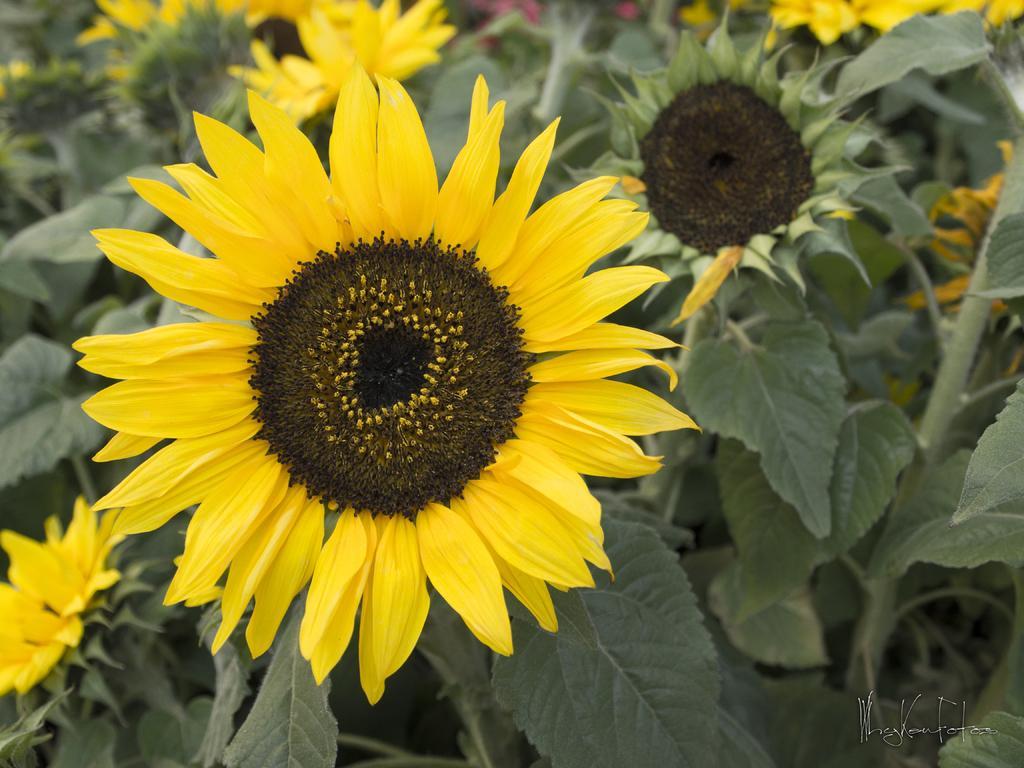Please provide a concise description of this image. In the image in the center,we can see plants and flowers,which are in yellow color. 